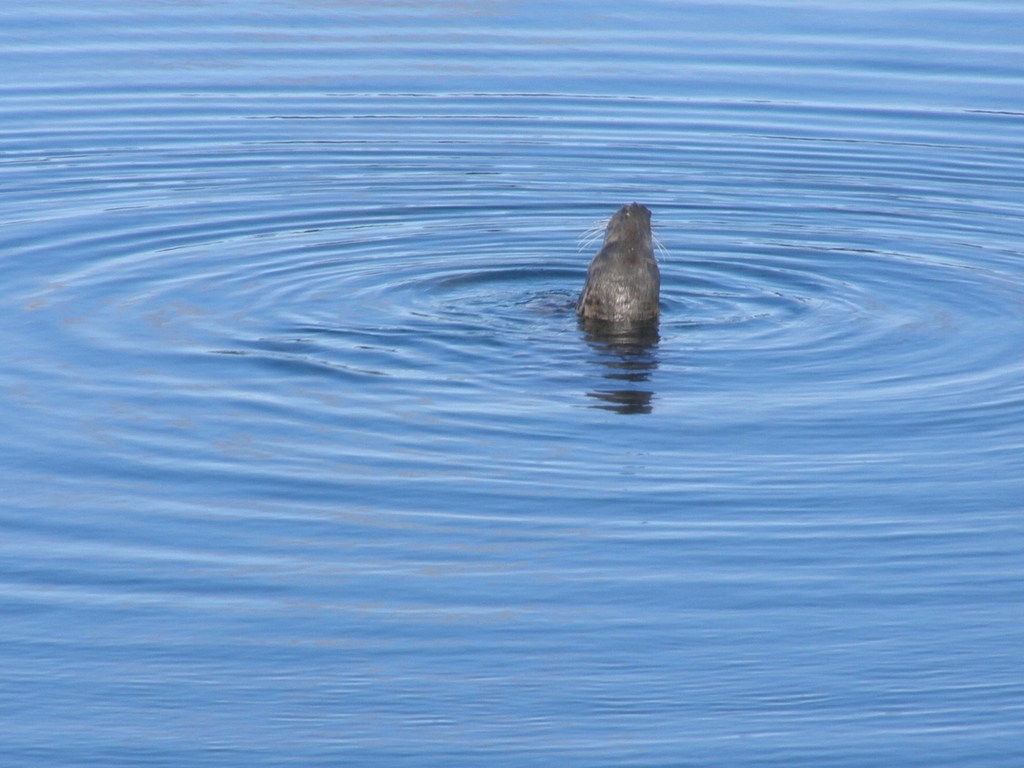Is there any sign of human activity in the vicinity of this marine creature? From this image, there are no visible signs of human activity nearby. The water is undisturbed aside from the ripples caused by the animal, and there are no boats, swimmers, or structures apparent in the vicinity. 